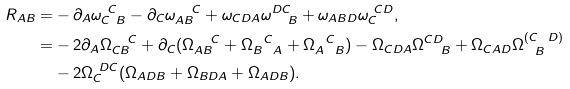<formula> <loc_0><loc_0><loc_500><loc_500>R _ { A B } = & - \partial _ { A } \omega _ { C \ B } ^ { \ C } - \partial _ { C } \omega _ { A B } ^ { \quad C } + \omega _ { C D A } \omega ^ { D C } _ { \quad B } + \omega _ { A B D } \omega _ { C } ^ { \ C D } , \\ = & - 2 \partial _ { A } \Omega _ { C B } ^ { \quad C } + \partial _ { C } ( \Omega _ { A B } ^ { \quad C } + \Omega _ { B \ \ A } ^ { \ \ C } + \Omega _ { A \ \ B } ^ { \ \ C } ) - \Omega _ { C D A } \Omega ^ { C D } _ { \quad B } + \Omega _ { C A D } \Omega ^ { ( C \ \ D ) } _ { \ \ B } \\ & - 2 \Omega _ { C } ^ { \ D C } ( \Omega _ { A D B } + \Omega _ { B D A } + \Omega _ { A D B } ) .</formula> 